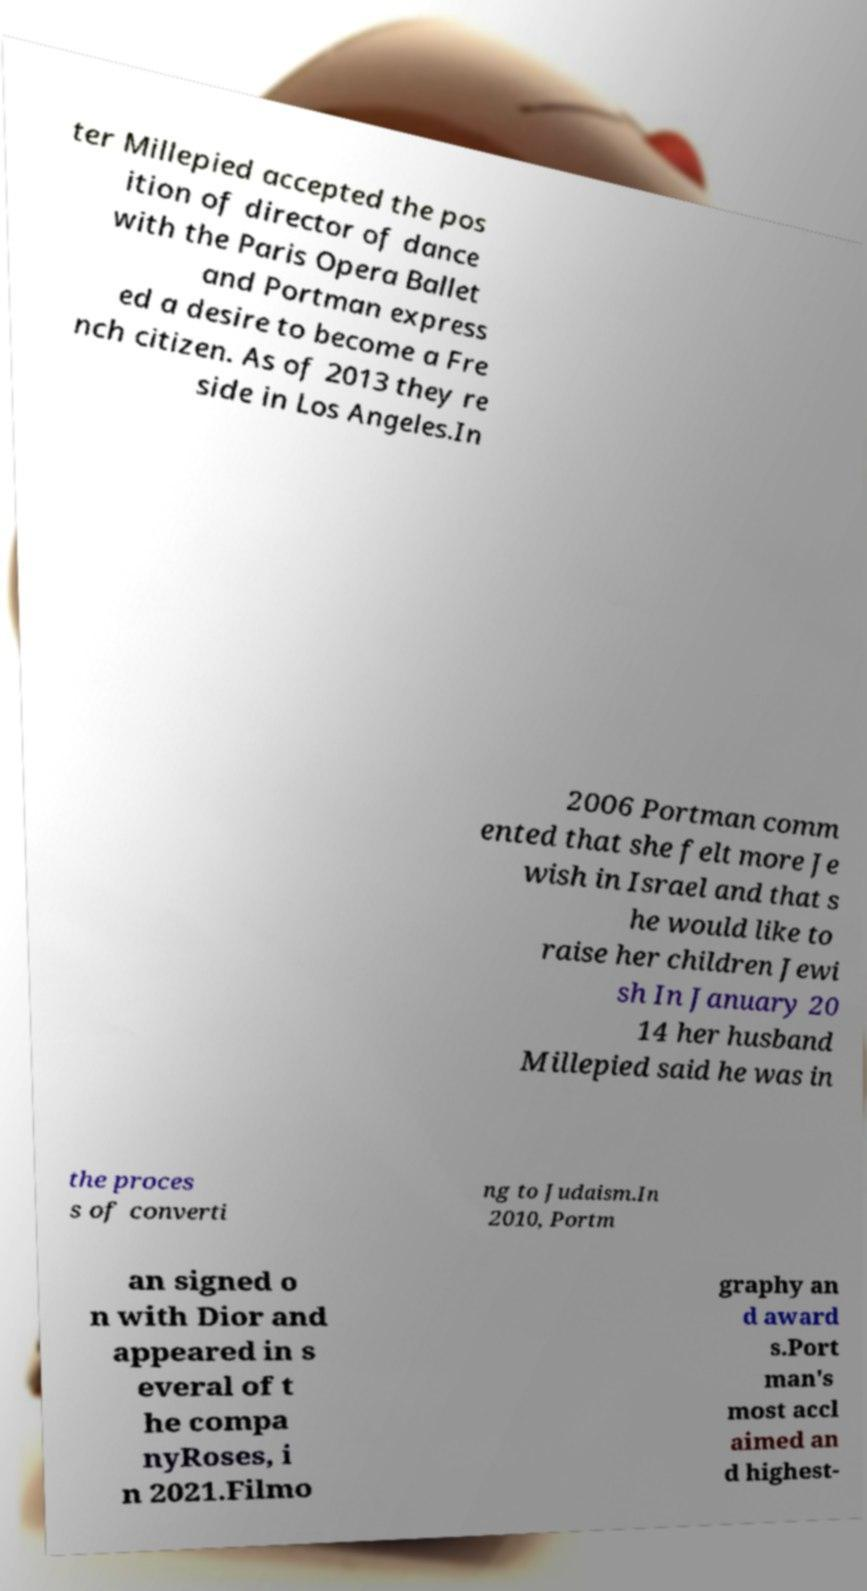Could you assist in decoding the text presented in this image and type it out clearly? ter Millepied accepted the pos ition of director of dance with the Paris Opera Ballet and Portman express ed a desire to become a Fre nch citizen. As of 2013 they re side in Los Angeles.In 2006 Portman comm ented that she felt more Je wish in Israel and that s he would like to raise her children Jewi sh In January 20 14 her husband Millepied said he was in the proces s of converti ng to Judaism.In 2010, Portm an signed o n with Dior and appeared in s everal of t he compa nyRoses, i n 2021.Filmo graphy an d award s.Port man's most accl aimed an d highest- 